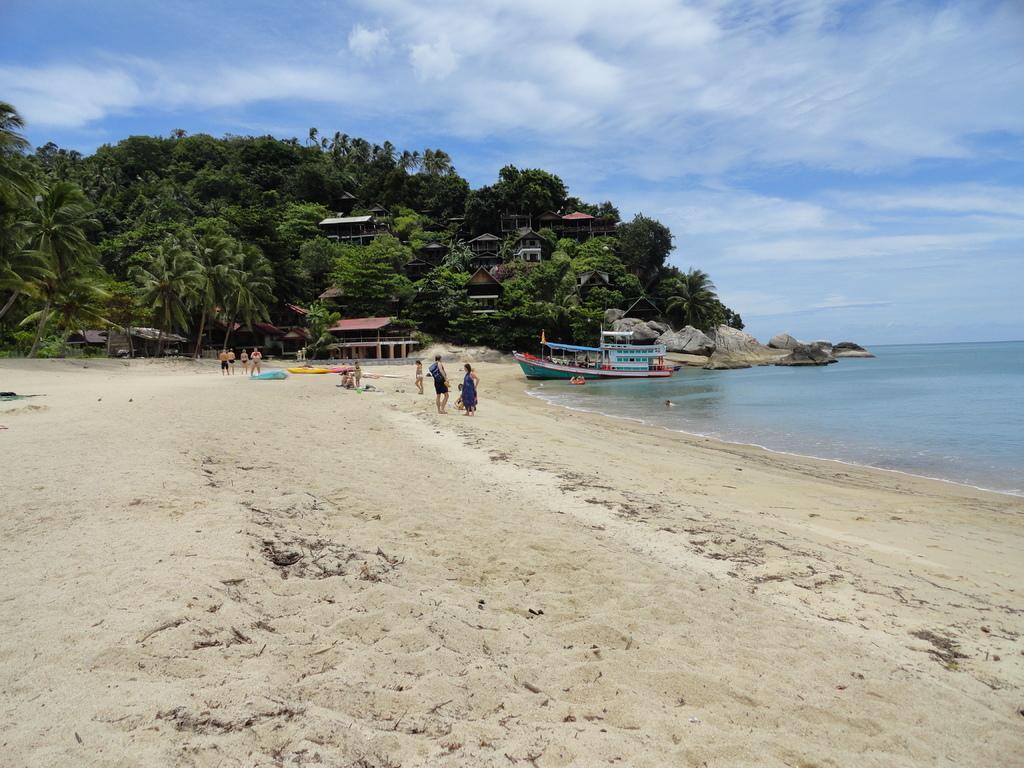How would you summarize this image in a sentence or two? In this image there is the sky, there are clouds in the sky, there are trees truncated towards the left of the image, there are buildings, there is a ship, there is sand, there are objects on the sand, there are persons, there are rocks, there is a beach. 